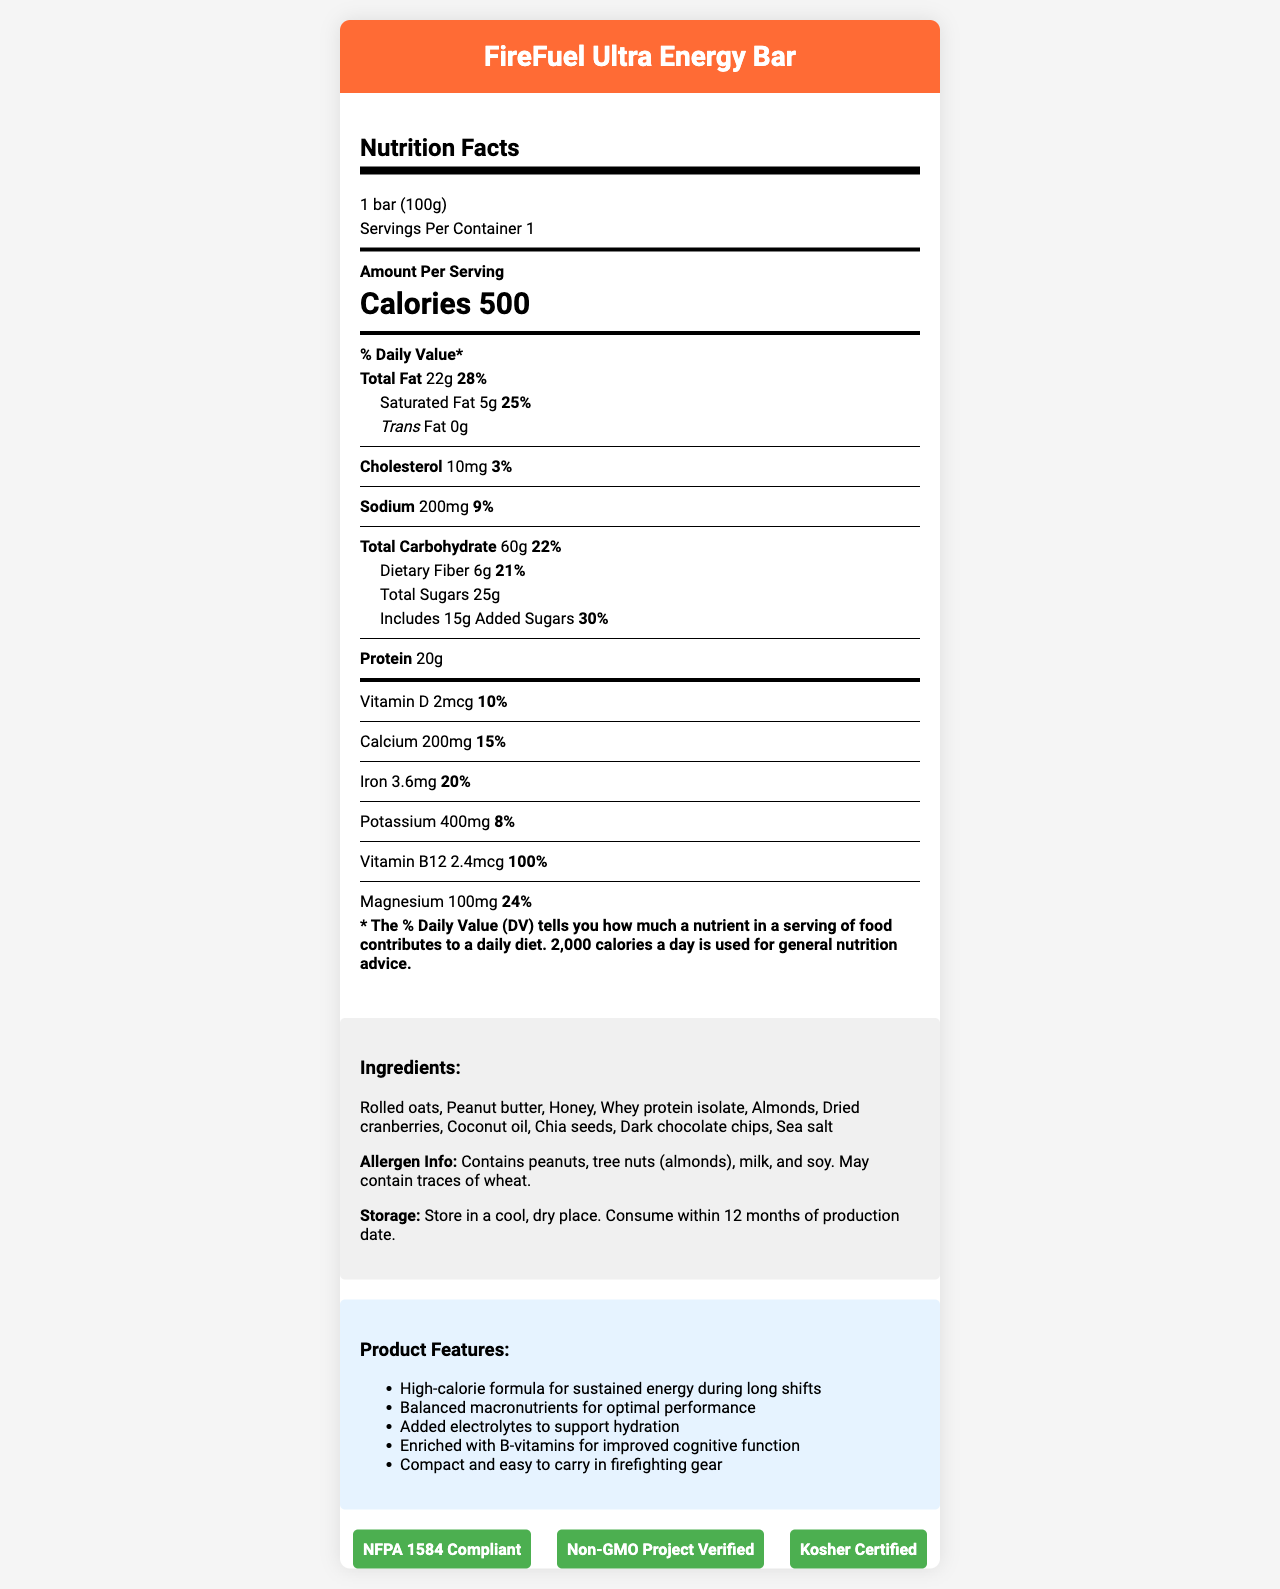what is the serving size for the FireFuel Ultra Energy Bar? The serving size is stated clearly in the nutrition facts section as "1 bar (100g)."
Answer: 1 bar (100g) what is the amount of protein in the FireFuel Ultra Energy Bar? In the nutrition facts section under "Amount Per Serving," it lists the protein content as 20g.
Answer: 20g how many grams of dietary fiber are in one serving? The nutrition facts label indicates "Dietary Fiber 6g" under the total carbohydrate section.
Answer: 6g does the FireFuel Ultra Energy Bar contain any trans fats? The nutrition facts state "<i>Trans</i> Fat 0g," indicating that there are no trans fats in the bar.
Answer: No what are the main ingredients in the FireFuel Ultra Energy Bar? The ingredients list is provided in the document and includes these items.
Answer: Rolled oats, Peanut butter, Honey, Whey protein isolate, Almonds, Dried cranberries, Coconut oil, Chia seeds, Dark chocolate chips, Sea salt how many calories are in one bar? The calories per serving are prominently displayed as 500 in the nutrition facts section.
Answer: 500 what is the percentage daily value of saturated fat? A. 10% B. 20% C. 25% D. 30% The document states "Saturated Fat 5g" with a daily value of 25%.
Answer: C which vitamin is present at 100% of the daily value? A. Vitamin D B. Calcium C. Vitamin B12 D. Iron Vitamin B12 has a daily value of 100% according to the nutrition facts.
Answer: C is the FireFuel Ultra Energy Bar kosher certified? The certifications section lists "Kosher Certified" among the product's certifications.
Answer: Yes summarize the main features and nutrients of the FireFuel Ultra Energy Bar. The document highlights the bar's nutritional content, its designed purpose, key features for performance, and certifications, providing a comprehensive view of the product.
Answer: The FireFuel Ultra Energy Bar is a high-calorie snack designed for firefighters. It provides 500 calories per serving with a balanced mix of macronutrients: 22g total fat, 60g carbohydrates (including 6g fiber and 25g total sugars), and 20g protein. Its features include sustained energy, electrolyte support, and added B-vitamins. It is compliant with NFPA 1584 and is Non-GMO Project Verified and Kosher Certified. how long can the FireFuel Ultra Energy Bar be stored before consumption? The storage instructions specify that the bar should be consumed within 12 months of the production date.
Answer: 12 months are there any allergens in the FireFuel Ultra Energy Bar? The allergen information lists peanuts, tree nuts (almonds), milk, and soy as potential allergens.
Answer: Yes what is the source of the 25g of total sugars in the bar? The document does not provide specific information about the sources of the 25g total sugars.
Answer: Not enough information what percentage of the daily value for magnesium is provided by the FireFuel Ultra Energy Bar? The nutrition facts indicate that the bar provides 100mg of magnesium, equating to 24% of the daily value.
Answer: 24% what are the additional health benefits of consuming the FireFuel Ultra Energy Bar besides calories and macronutrients? The document mentions added electrolytes for hydration support and B-vitamins for improved cognitive function among the product features.
Answer: Added electrolytes, B-vitamins for cognitive function 